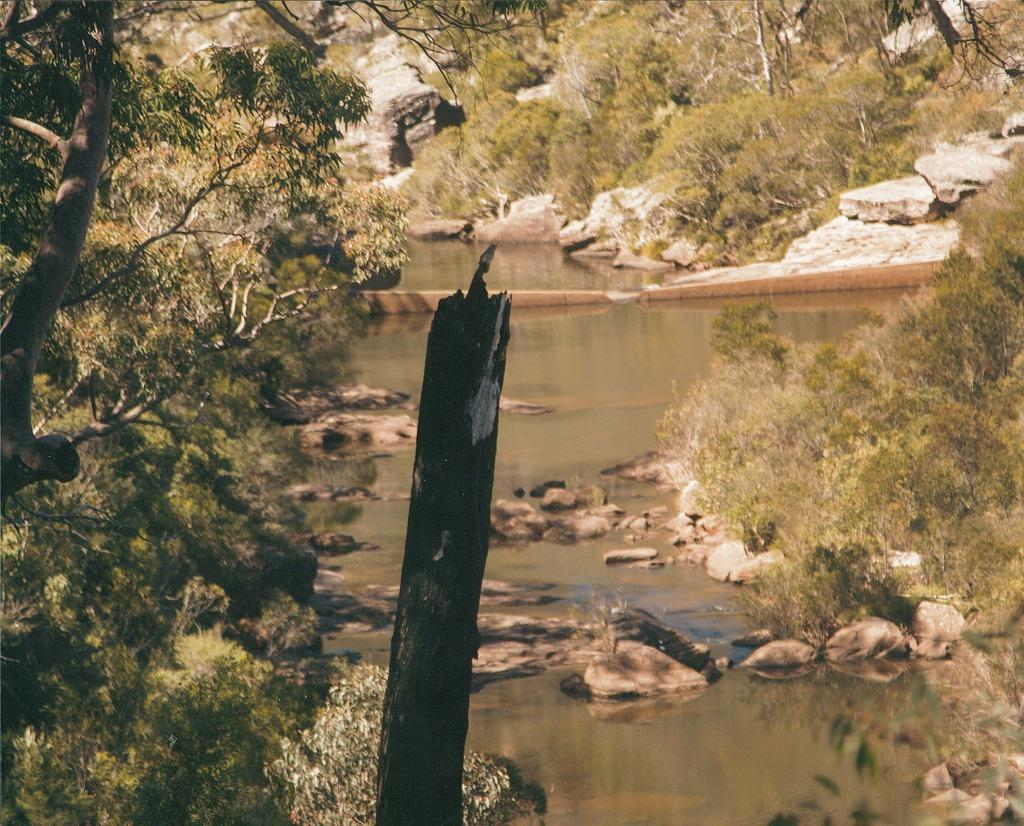What type of natural elements can be seen in the image? There are trees and rocks visible in the image. What is present at the bottom of the image? There is water visible at the bottom of the image. Can you describe the tree trunk in the foreground of the image? Yes, there is a tree trunk in the foreground of the image. What type of vegetable is growing on the tree trunk in the image? There are no vegetables growing on the tree trunk in the image; it is a tree trunk. How does the jelly interact with the rocks in the image? There is no jelly present in the image, so it cannot interact with the rocks. 